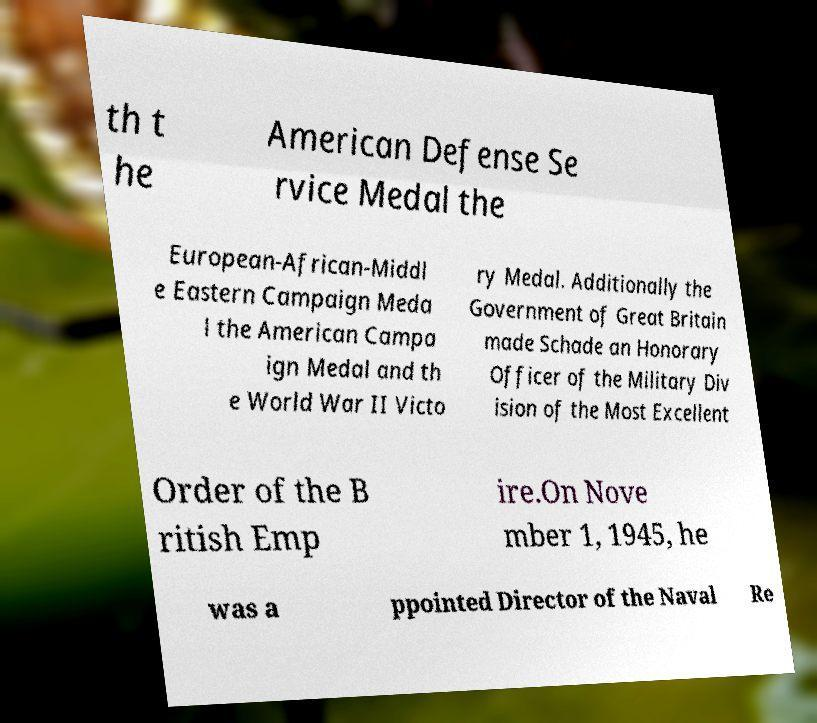I need the written content from this picture converted into text. Can you do that? th t he American Defense Se rvice Medal the European-African-Middl e Eastern Campaign Meda l the American Campa ign Medal and th e World War II Victo ry Medal. Additionally the Government of Great Britain made Schade an Honorary Officer of the Military Div ision of the Most Excellent Order of the B ritish Emp ire.On Nove mber 1, 1945, he was a ppointed Director of the Naval Re 